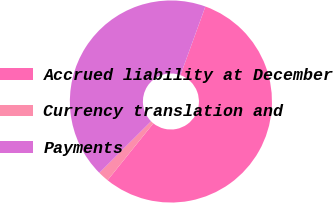Convert chart. <chart><loc_0><loc_0><loc_500><loc_500><pie_chart><fcel>Accrued liability at December<fcel>Currency translation and<fcel>Payments<nl><fcel>55.24%<fcel>1.74%<fcel>43.02%<nl></chart> 